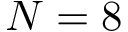Convert formula to latex. <formula><loc_0><loc_0><loc_500><loc_500>N = 8</formula> 